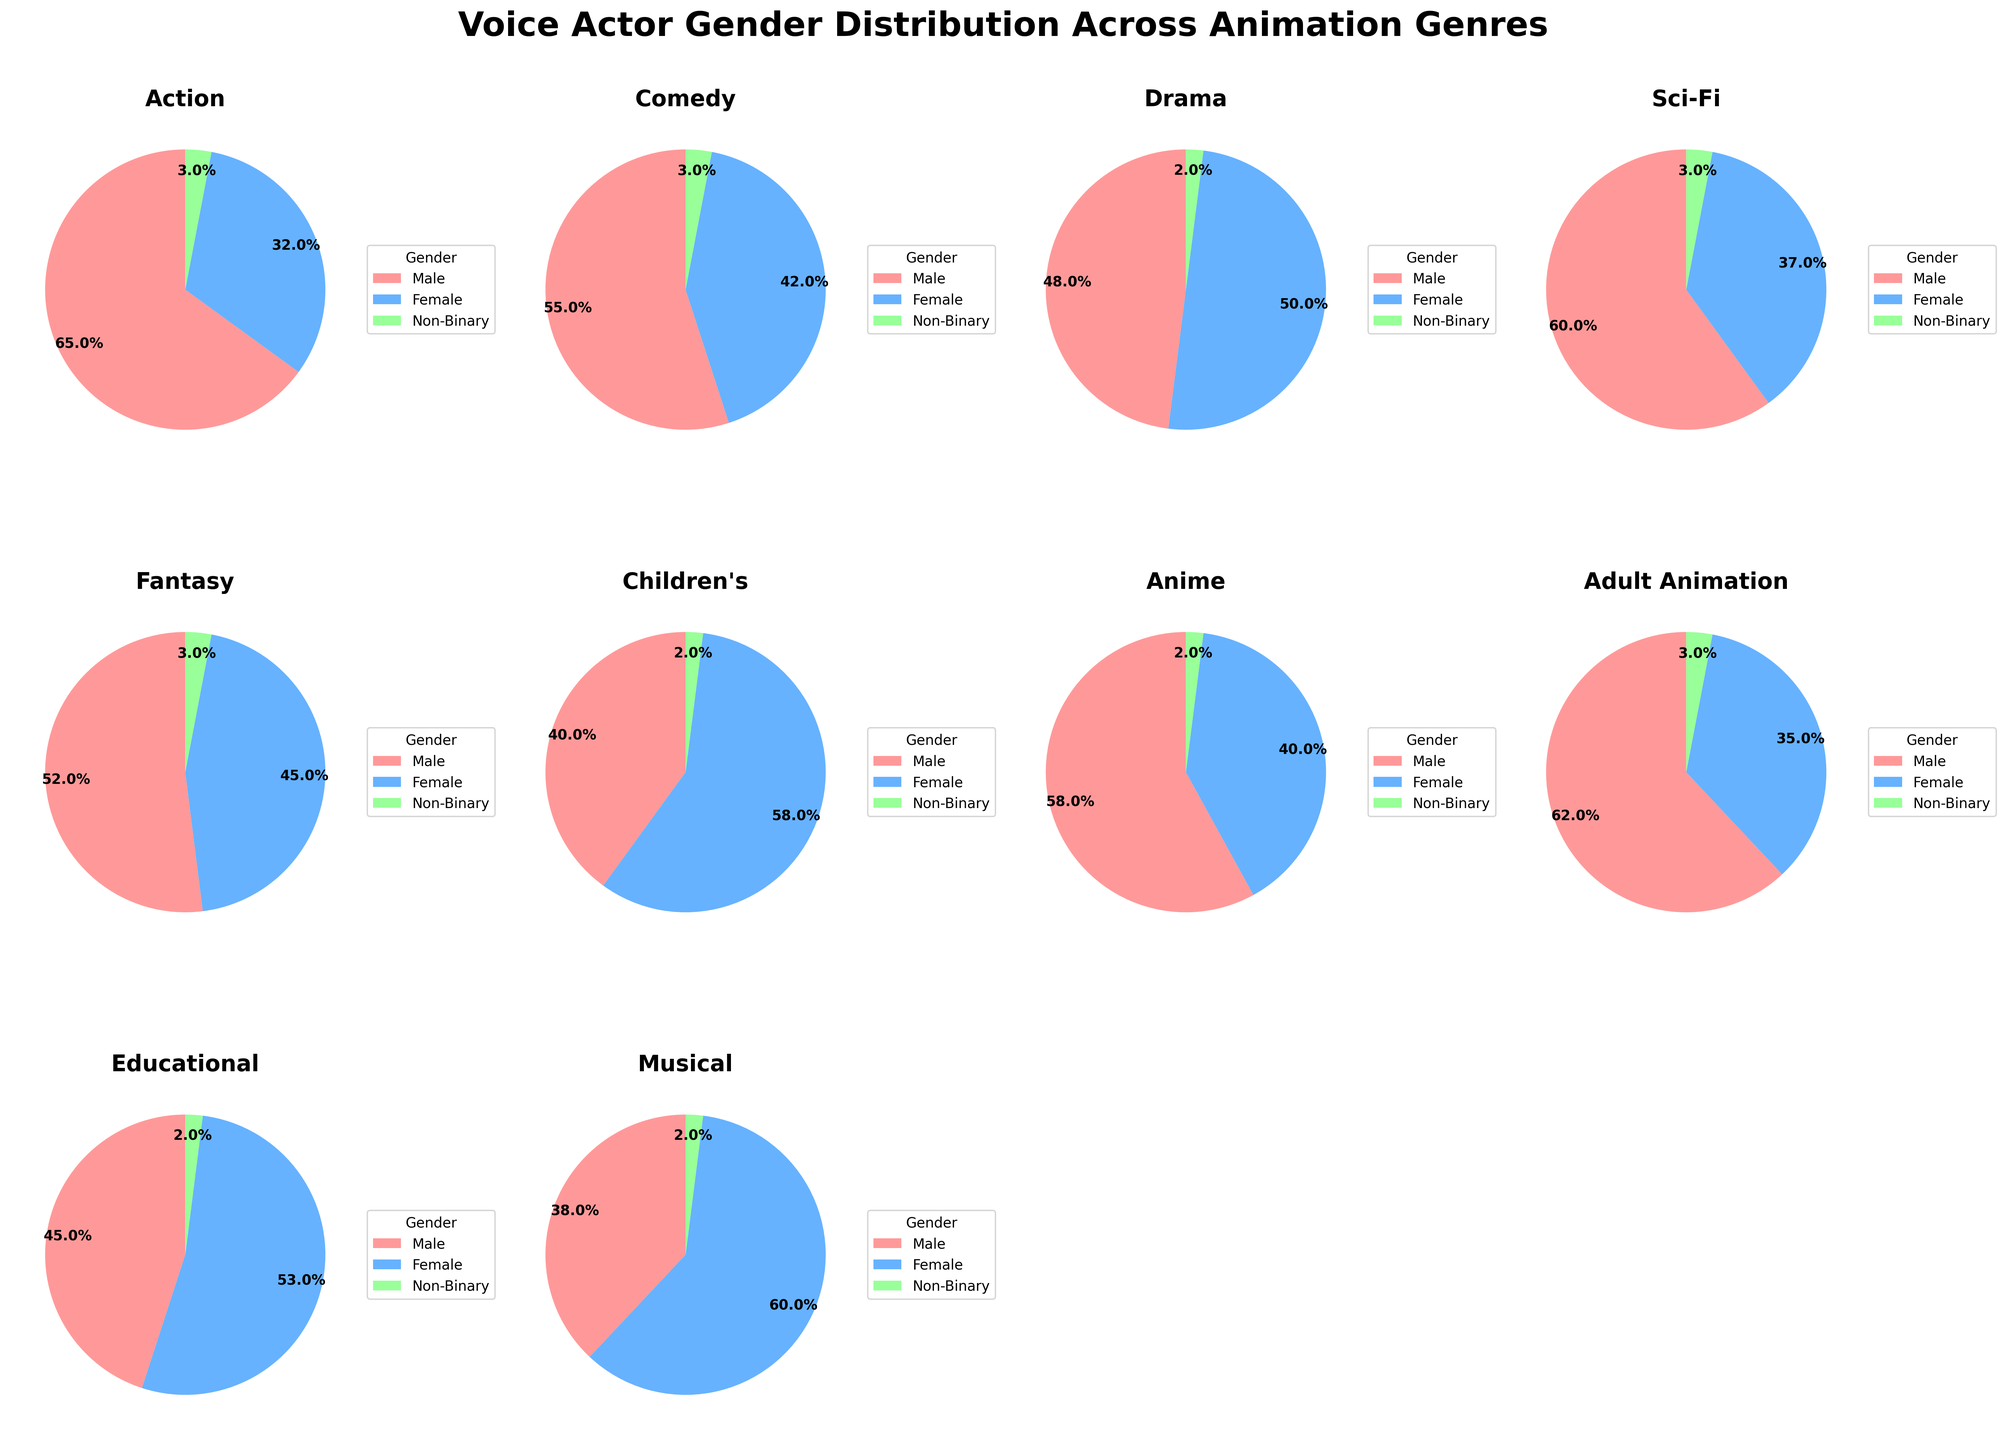Which genre has the highest percentage of female voice actors? By observing the pie charts, note the genre where the 'Female' portion is the largest. The 'Children's' genre has a large pink section representing females, almost 60% of the total.
Answer: Children's Which genre shows the most balanced gender distribution? Look for the chart where the male and female sections are about the same size. Drama has almost equal sections for males and females, each around 48-50%, making it the most balanced.
Answer: Drama Between Anime and Sci-Fi, which has a higher percentage of female voice actors? Compare the female sections in the Anime and Sci-Fi pie charts. Anime has approximately 40% female actors, while Sci-Fi has around 37% female actors.
Answer: Anime What is the percentage difference of female voice actors between Fantasy and Action genres? Observe the female sections in Fantasy (approximately 45%) and Action (approximately 32%). The difference is 45% - 32% = 13%.
Answer: 13% Which genre has the smallest percentage of non-binary voice actors? Check the smallest segment in each pie chart representing non-binary. Most genres have around 2-3%, but Drama has the smallest at approximately 2%.
Answer: Drama In which genre do male voice actors dominate the most? Look for the genre with the largest male section. Action has the largest male section at around 65%, noticeably dominating this genre.
Answer: Action Which genre features the highest percentage of voice actors who are not male (including female and non-binary)? Calculate the combined percentage of female and non-binary actors in all genres. The 'Children's' genre has the highest combined, approximately (58% + 2%) = 60%.
Answer: Children's If you combine the percentage of female voice actors in Comedy and Educational genres, what value do you get? Sum the female sections in Comedy (approximately 42%) and Educational (approximately 53%). The total is 42% + 53% = 95%.
Answer: 95% Which genre has an equal percentage of non-binary voice actors as the Sci-Fi genre? Compare each genre's non-binary sections with Sci-Fi, which has about 3%. The Action and Comedy genres also have 3% non-binary actors each.
Answer: Action, Comedy What is the average percentage of male voice actors across the listed genres? Calculate the sum of the male sections in all genres and divide by the number of genres. Sum is (65 + 55 + 48 + 60 + 52 + 40 + 58 + 62 + 45 + 38) = 523. There are 10 genres. The average is 523/10 = 52.3%.
Answer: 52.3% 